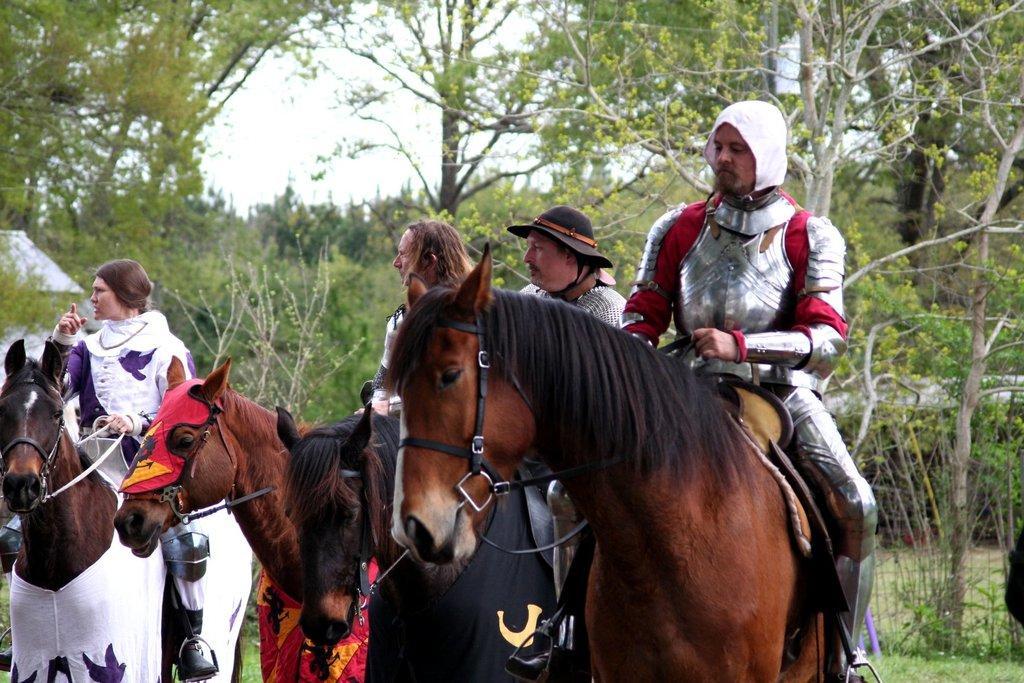How would you summarize this image in a sentence or two? In this image we can see four people who are sitting on a horses. In the background we can see trees and a sky. 